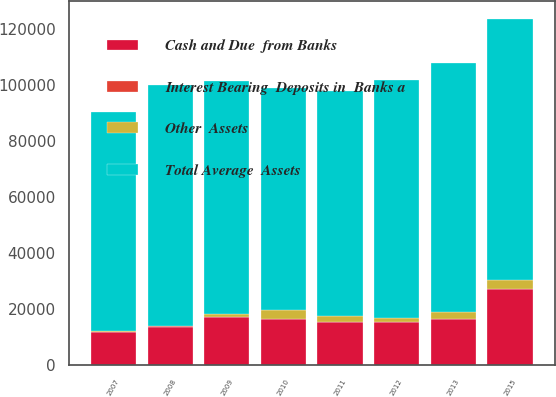Convert chart. <chart><loc_0><loc_0><loc_500><loc_500><stacked_bar_chart><ecel><fcel>2015<fcel>2013<fcel>2012<fcel>2011<fcel>2010<fcel>2009<fcel>2008<fcel>2007<nl><fcel>Total Average  Assets<fcel>93339<fcel>89093<fcel>84822<fcel>80214<fcel>79232<fcel>83391<fcel>85835<fcel>78348<nl><fcel>Interest Bearing  Deposits in  Banks a<fcel>1<fcel>1<fcel>2<fcel>1<fcel>11<fcel>12<fcel>438<fcel>257<nl><fcel>Other  Assets<fcel>3257<fcel>2416<fcel>1493<fcel>2030<fcel>3317<fcel>1023<fcel>183<fcel>147<nl><fcel>Cash and Due  from Banks<fcel>26987<fcel>16444<fcel>15319<fcel>15437<fcel>16371<fcel>17100<fcel>13424<fcel>11630<nl></chart> 